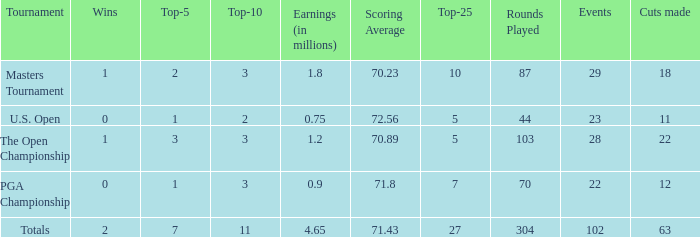How many top 10s when he had under 1 top 5s? None. 